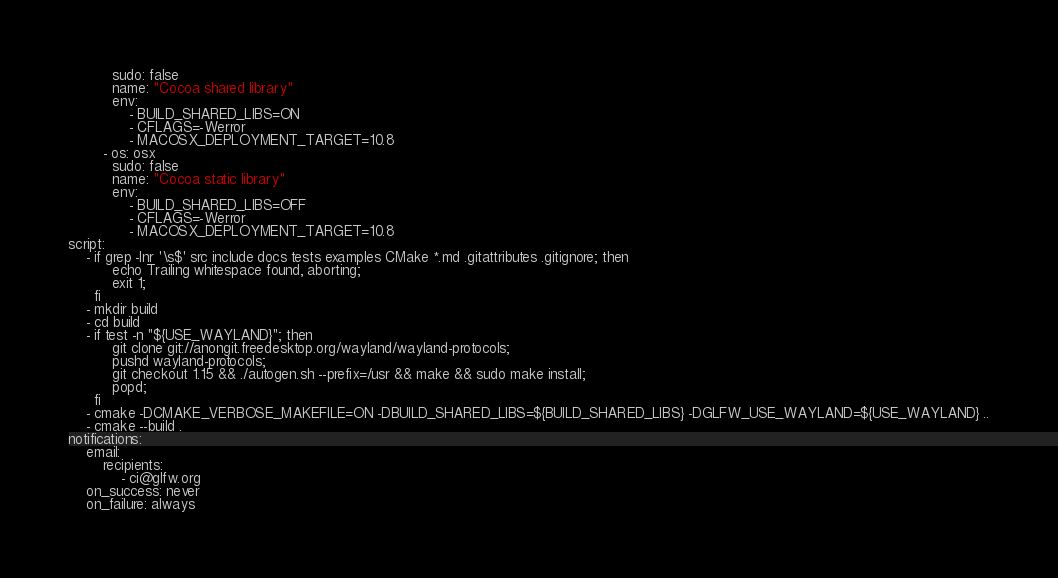Convert code to text. <code><loc_0><loc_0><loc_500><loc_500><_YAML_>          sudo: false
          name: "Cocoa shared library"
          env:
              - BUILD_SHARED_LIBS=ON
              - CFLAGS=-Werror
              - MACOSX_DEPLOYMENT_TARGET=10.8
        - os: osx
          sudo: false
          name: "Cocoa static library"
          env:
              - BUILD_SHARED_LIBS=OFF
              - CFLAGS=-Werror
              - MACOSX_DEPLOYMENT_TARGET=10.8
script:
    - if grep -Inr '\s$' src include docs tests examples CMake *.md .gitattributes .gitignore; then
          echo Trailing whitespace found, aborting;
          exit 1;
      fi
    - mkdir build
    - cd build
    - if test -n "${USE_WAYLAND}"; then
          git clone git://anongit.freedesktop.org/wayland/wayland-protocols;
          pushd wayland-protocols;
          git checkout 1.15 && ./autogen.sh --prefix=/usr && make && sudo make install;
          popd;
      fi
    - cmake -DCMAKE_VERBOSE_MAKEFILE=ON -DBUILD_SHARED_LIBS=${BUILD_SHARED_LIBS} -DGLFW_USE_WAYLAND=${USE_WAYLAND} ..
    - cmake --build .
notifications:
    email:
        recipients:
            - ci@glfw.org
    on_success: never
    on_failure: always
</code> 